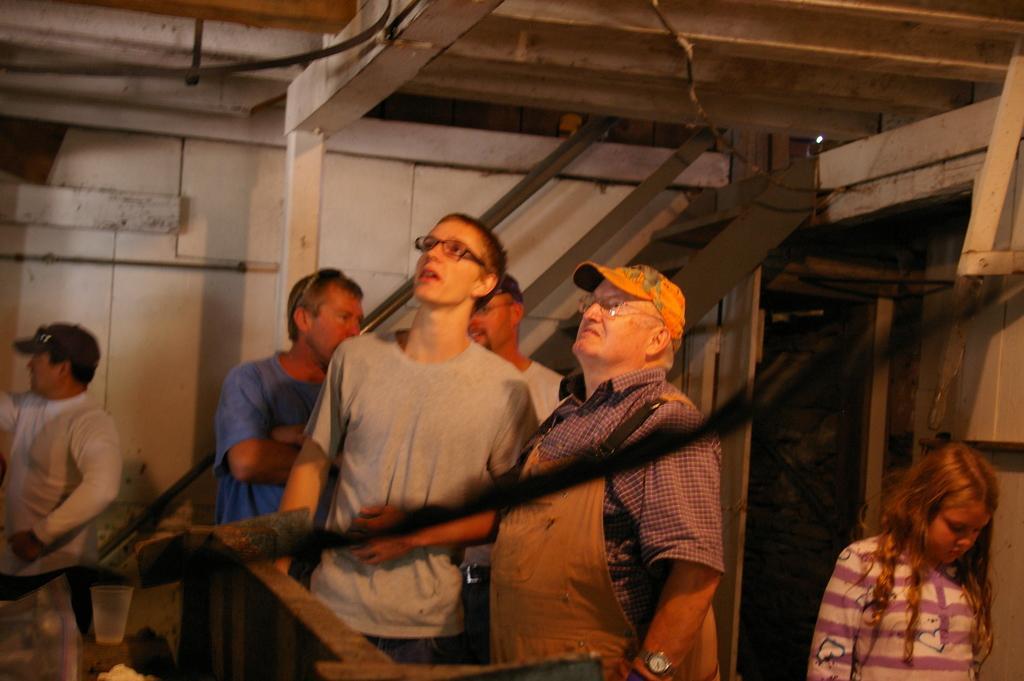How would you summarize this image in a sentence or two? In the foreground of this image, there are persons standing and a metal curved object and a girl is on the right side. In the background, there are stairs, door, wooden wall and the ceiling. 